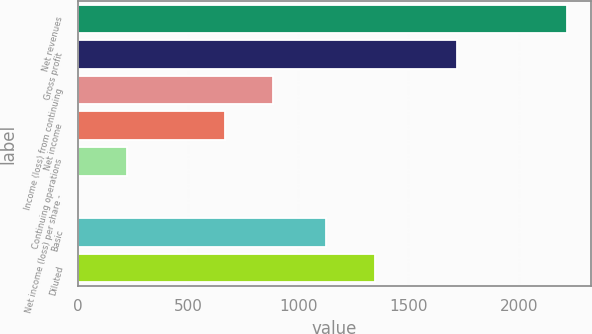Convert chart to OTSL. <chart><loc_0><loc_0><loc_500><loc_500><bar_chart><fcel>Net revenues<fcel>Gross profit<fcel>Income (loss) from continuing<fcel>Net income<fcel>Continuing operations<fcel>Net income (loss) per share -<fcel>Basic<fcel>Diluted<nl><fcel>2217<fcel>1719<fcel>887<fcel>665.34<fcel>222.02<fcel>0.36<fcel>1126<fcel>1347.66<nl></chart> 